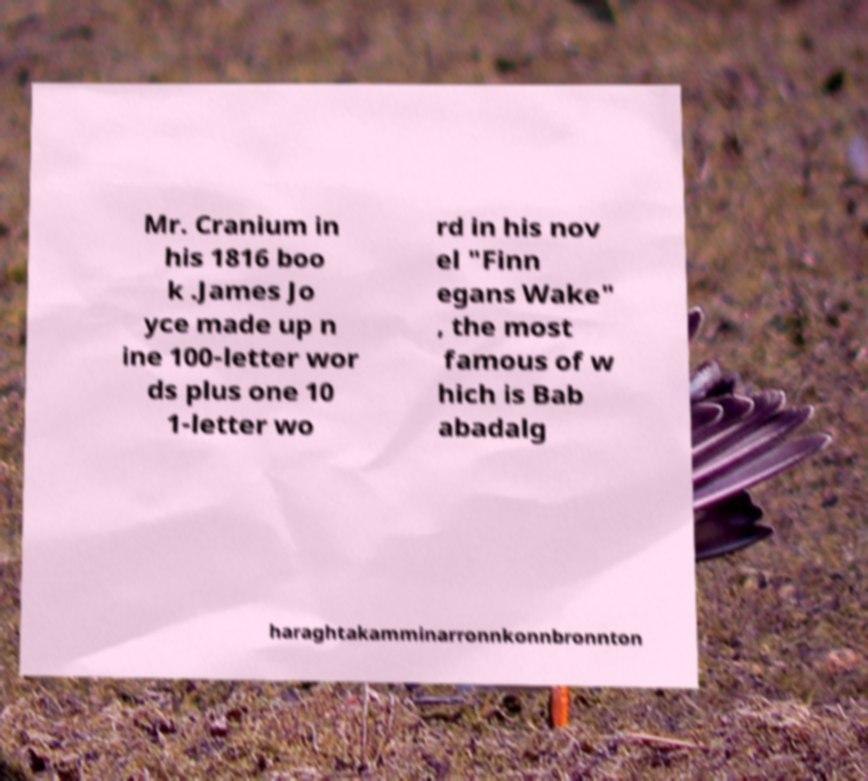What messages or text are displayed in this image? I need them in a readable, typed format. Mr. Cranium in his 1816 boo k .James Jo yce made up n ine 100-letter wor ds plus one 10 1-letter wo rd in his nov el "Finn egans Wake" , the most famous of w hich is Bab abadalg haraghtakamminarronnkonnbronnton 